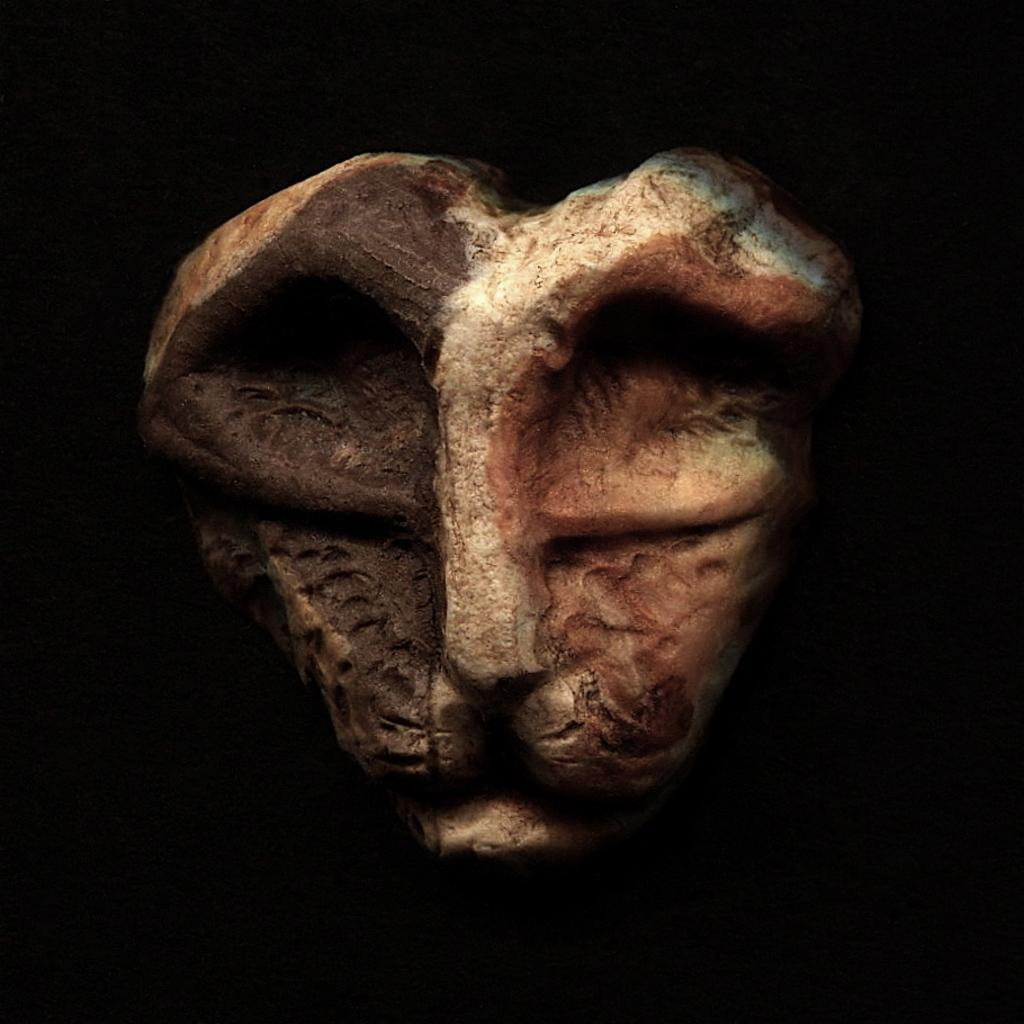What is the main subject of the image? There is a sculpture in the image. Can you describe the background of the image? The background of the image is dark. What type of teaching method is being demonstrated by the sculpture in the image? There is no teaching method being demonstrated by the sculpture in the image, as it is a static object and not a person or group of people. 